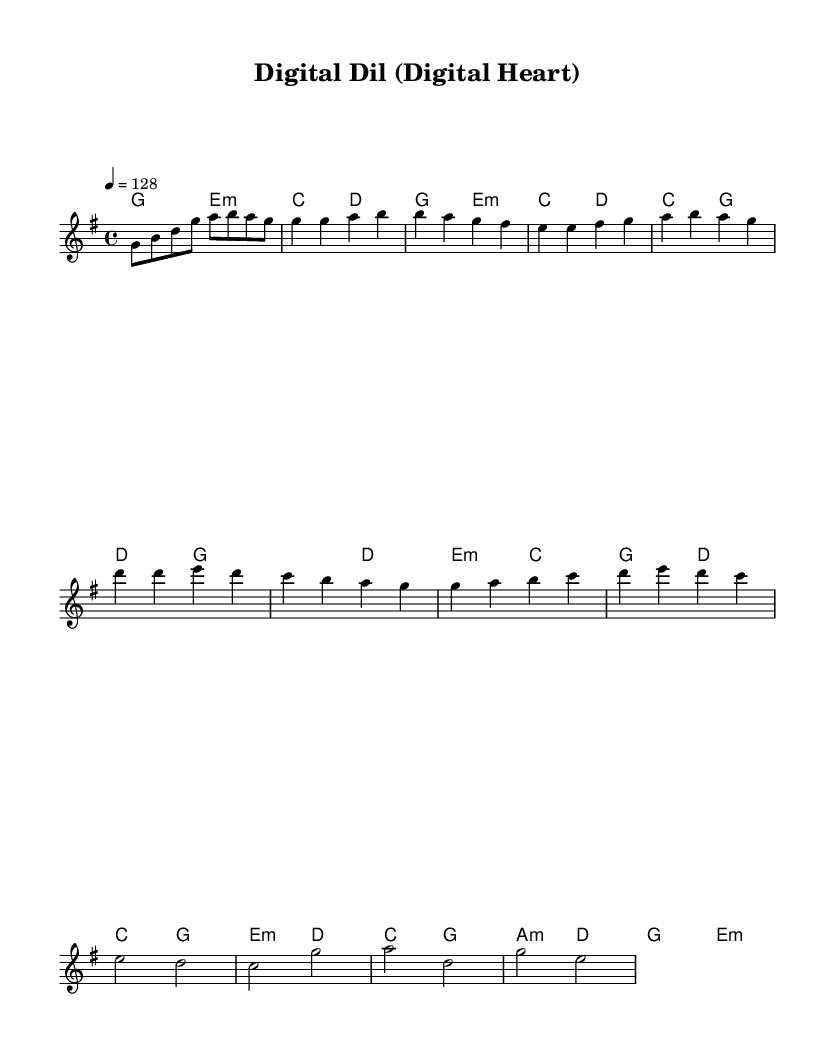What is the key signature of this music? The key signature indicated at the beginning of the music is G major, which has one sharp, F#.
Answer: G major What is the time signature of this music? The time signature is shown near the beginning of the piece and is notated as 4/4, meaning there are four beats in each measure.
Answer: 4/4 What is the tempo marking of this piece? The tempo is specified as quarter note equals 128, indicating that there should be 128 quarter note beats per minute.
Answer: 128 How many measures are there in the intro section? By counting the measures in the intro section, it can be observed that there are four measures present.
Answer: 4 What is the primary chord used in the chorus? In the chorus, the primary chords that are played include G major and E minor, which are prominently used throughout.
Answer: G major, E minor Which section has a different style indicated by the musical terms? The bridge section typically acts as a contrast to the verse and chorus, and in this piece, it features a different pacing and harmony.
Answer: Bridge How many distinct sections are identified in the music? By analyzing the structure of the music, there are four distinct sections: Intro, Verse 1, Chorus, and Bridge.
Answer: 4 